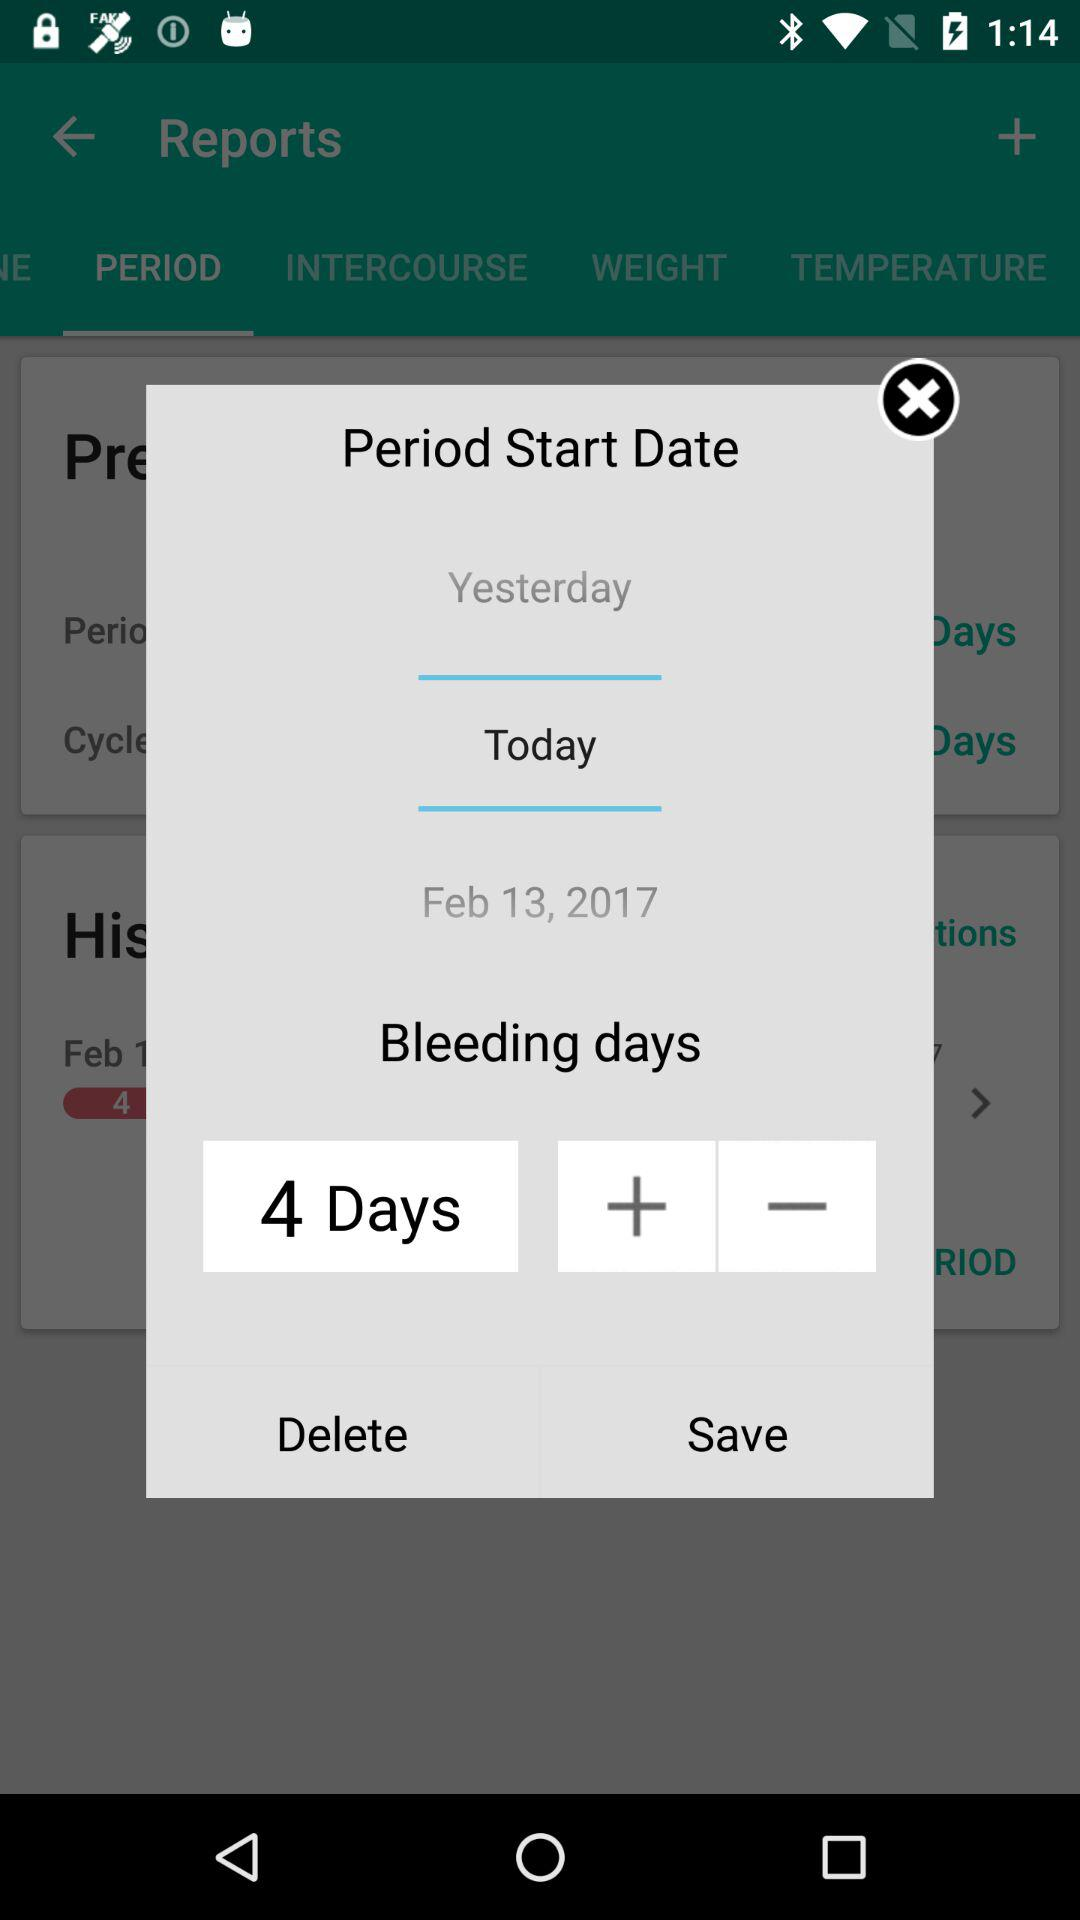When does the period start? The period starts today. 